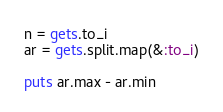<code> <loc_0><loc_0><loc_500><loc_500><_Ruby_>n = gets.to_i
ar = gets.split.map(&:to_i)

puts ar.max - ar.min
</code> 